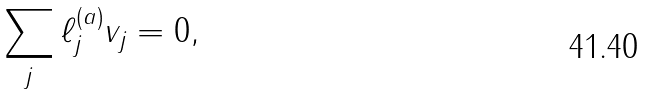Convert formula to latex. <formula><loc_0><loc_0><loc_500><loc_500>\sum _ { j } \ell _ { j } ^ { ( a ) } v _ { j } = 0 ,</formula> 